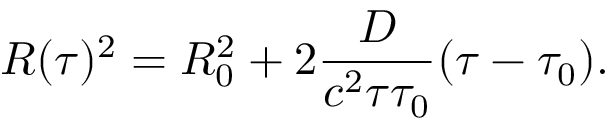<formula> <loc_0><loc_0><loc_500><loc_500>R ( \tau ) ^ { 2 } = R _ { 0 } ^ { 2 } + 2 \frac { D } { { c ^ { 2 } } { \tau \tau _ { 0 } } } ( \tau - \tau _ { 0 } ) .</formula> 